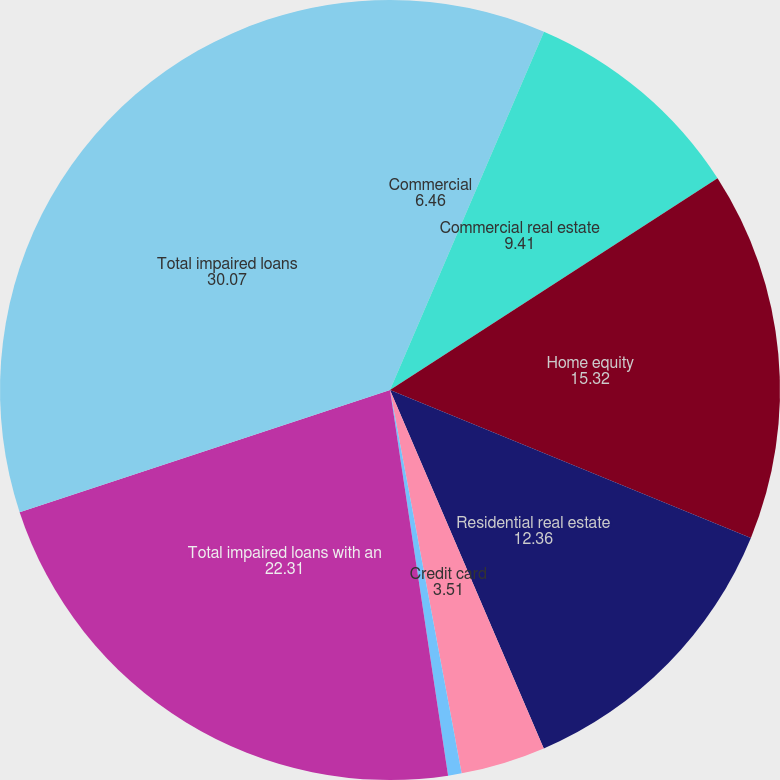Convert chart. <chart><loc_0><loc_0><loc_500><loc_500><pie_chart><fcel>Commercial<fcel>Commercial real estate<fcel>Home equity<fcel>Residential real estate<fcel>Credit card<fcel>Other consumer<fcel>Total impaired loans with an<fcel>Total impaired loans<nl><fcel>6.46%<fcel>9.41%<fcel>15.32%<fcel>12.36%<fcel>3.51%<fcel>0.56%<fcel>22.31%<fcel>30.07%<nl></chart> 